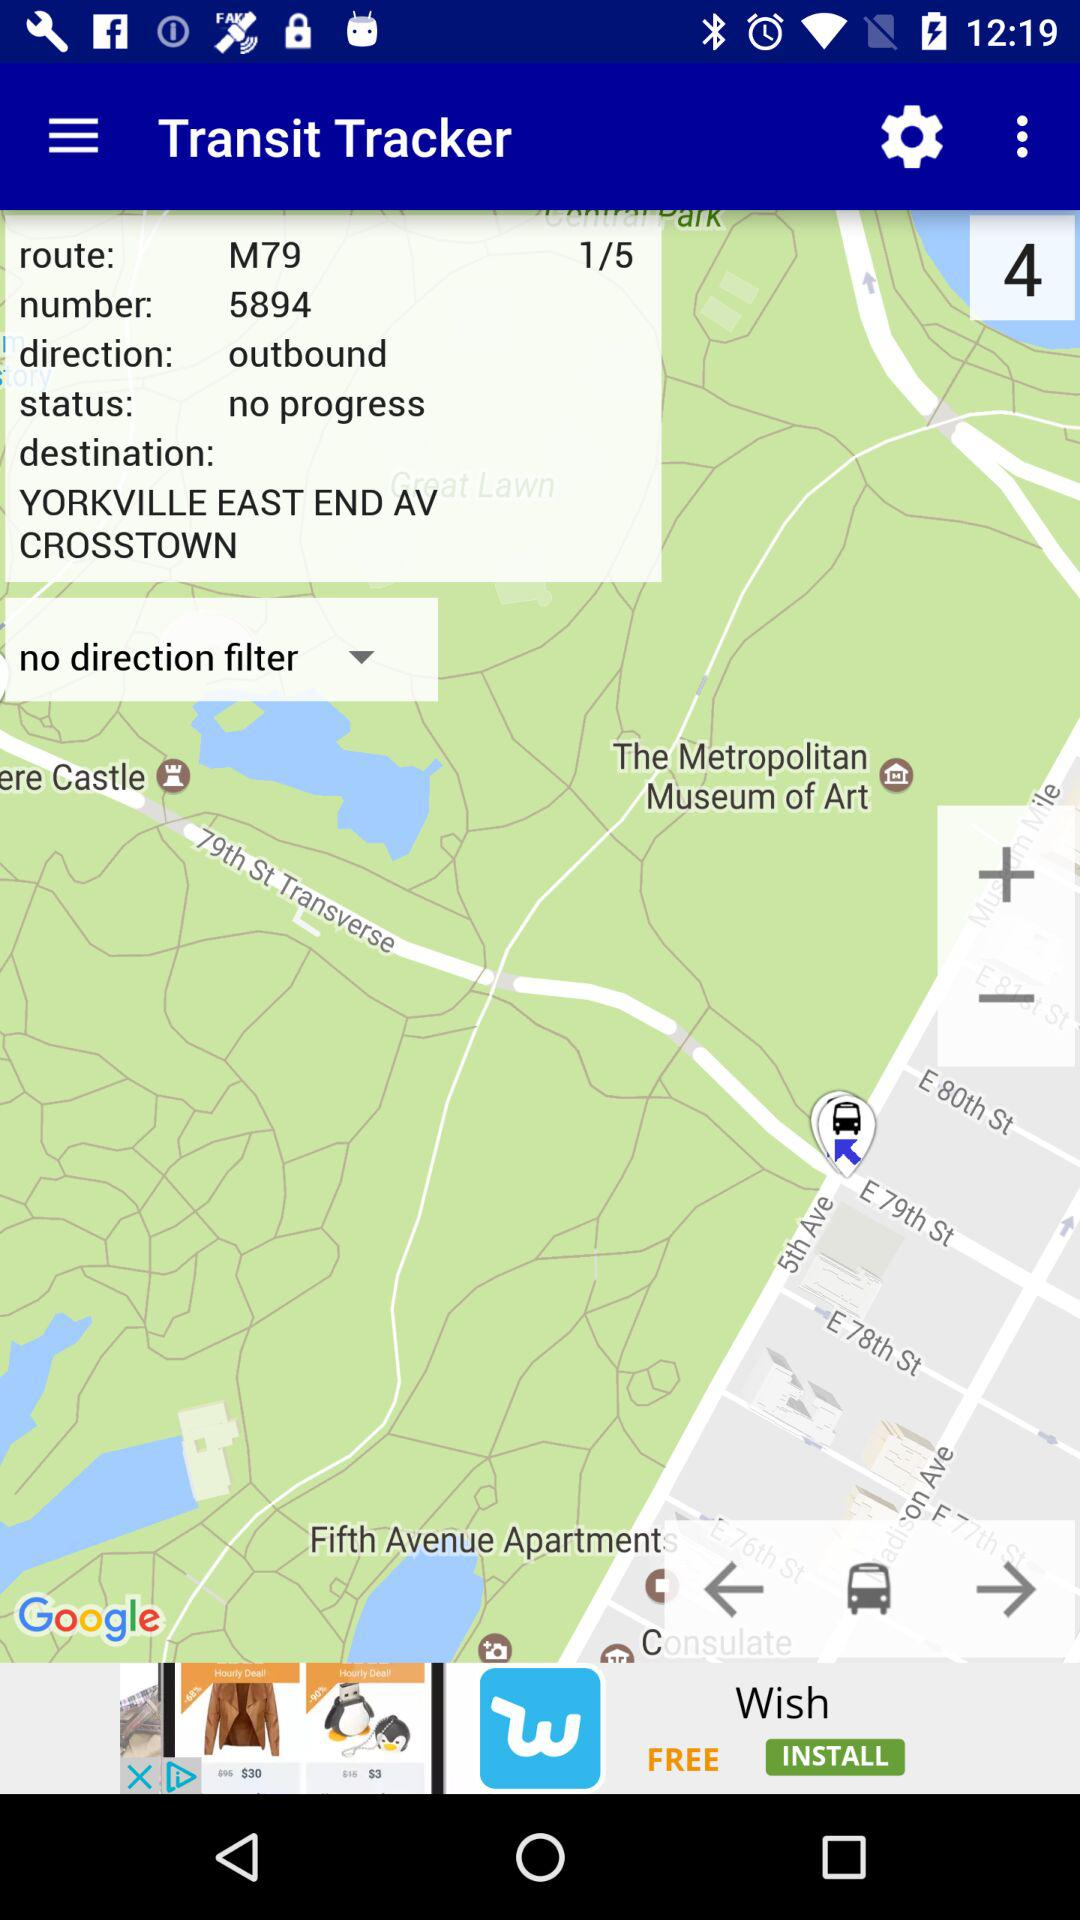What is the route number? The route number is M79. 